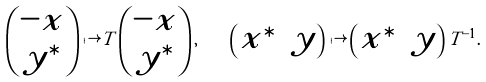<formula> <loc_0><loc_0><loc_500><loc_500>\begin{pmatrix} - x \\ y ^ { \ast } \end{pmatrix} \mapsto T \begin{pmatrix} - x \\ y ^ { \ast } \end{pmatrix} , \quad \begin{pmatrix} x ^ { \ast } & y \end{pmatrix} \mapsto \begin{pmatrix} x ^ { \ast } & y \end{pmatrix} T ^ { - 1 } .</formula> 